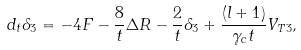<formula> <loc_0><loc_0><loc_500><loc_500>d _ { t } \delta _ { 3 } = - 4 F - \frac { 8 } { t } \Delta R - \frac { 2 } { t } \delta _ { 3 } + \frac { ( l + 1 ) } { \gamma _ { c } t } V _ { T 3 } ,</formula> 